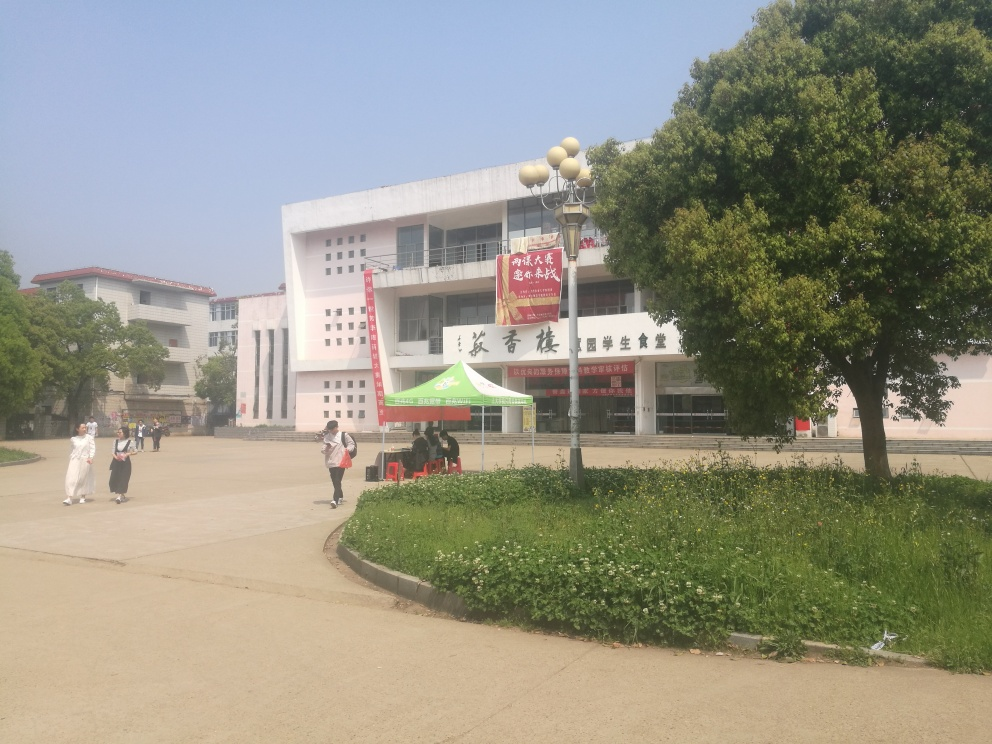What does the presence of the green canopy tent suggest about this location? The green canopy tent suggests that there might be a temporary event, such as a fair, information booth, or outdoor market. It's likely set up to either provide information to passersby, serve as a gathering point, or possibly offer goods or services. 